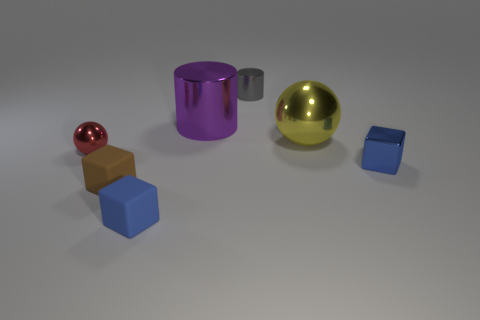Add 1 large purple rubber blocks. How many objects exist? 8 Subtract all balls. How many objects are left? 5 Subtract 1 gray cylinders. How many objects are left? 6 Subtract all small gray metallic cylinders. Subtract all large matte spheres. How many objects are left? 6 Add 3 blue rubber blocks. How many blue rubber blocks are left? 4 Add 5 brown blocks. How many brown blocks exist? 6 